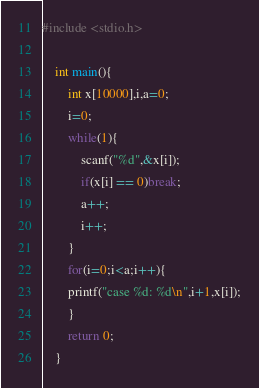Convert code to text. <code><loc_0><loc_0><loc_500><loc_500><_C_>#include <stdio.h>
    
    int main(){
        int x[10000],i,a=0;
        i=0;
        while(1){
            scanf("%d",&x[i]);
            if(x[i] == 0)break;
            a++;
            i++;
        }
        for(i=0;i<a;i++){
        printf("case %d: %d\n",i+1,x[i]);
        }
        return 0;
    }</code> 